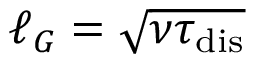<formula> <loc_0><loc_0><loc_500><loc_500>{ \ell _ { G } = \sqrt { \nu \tau _ { d i s } } }</formula> 